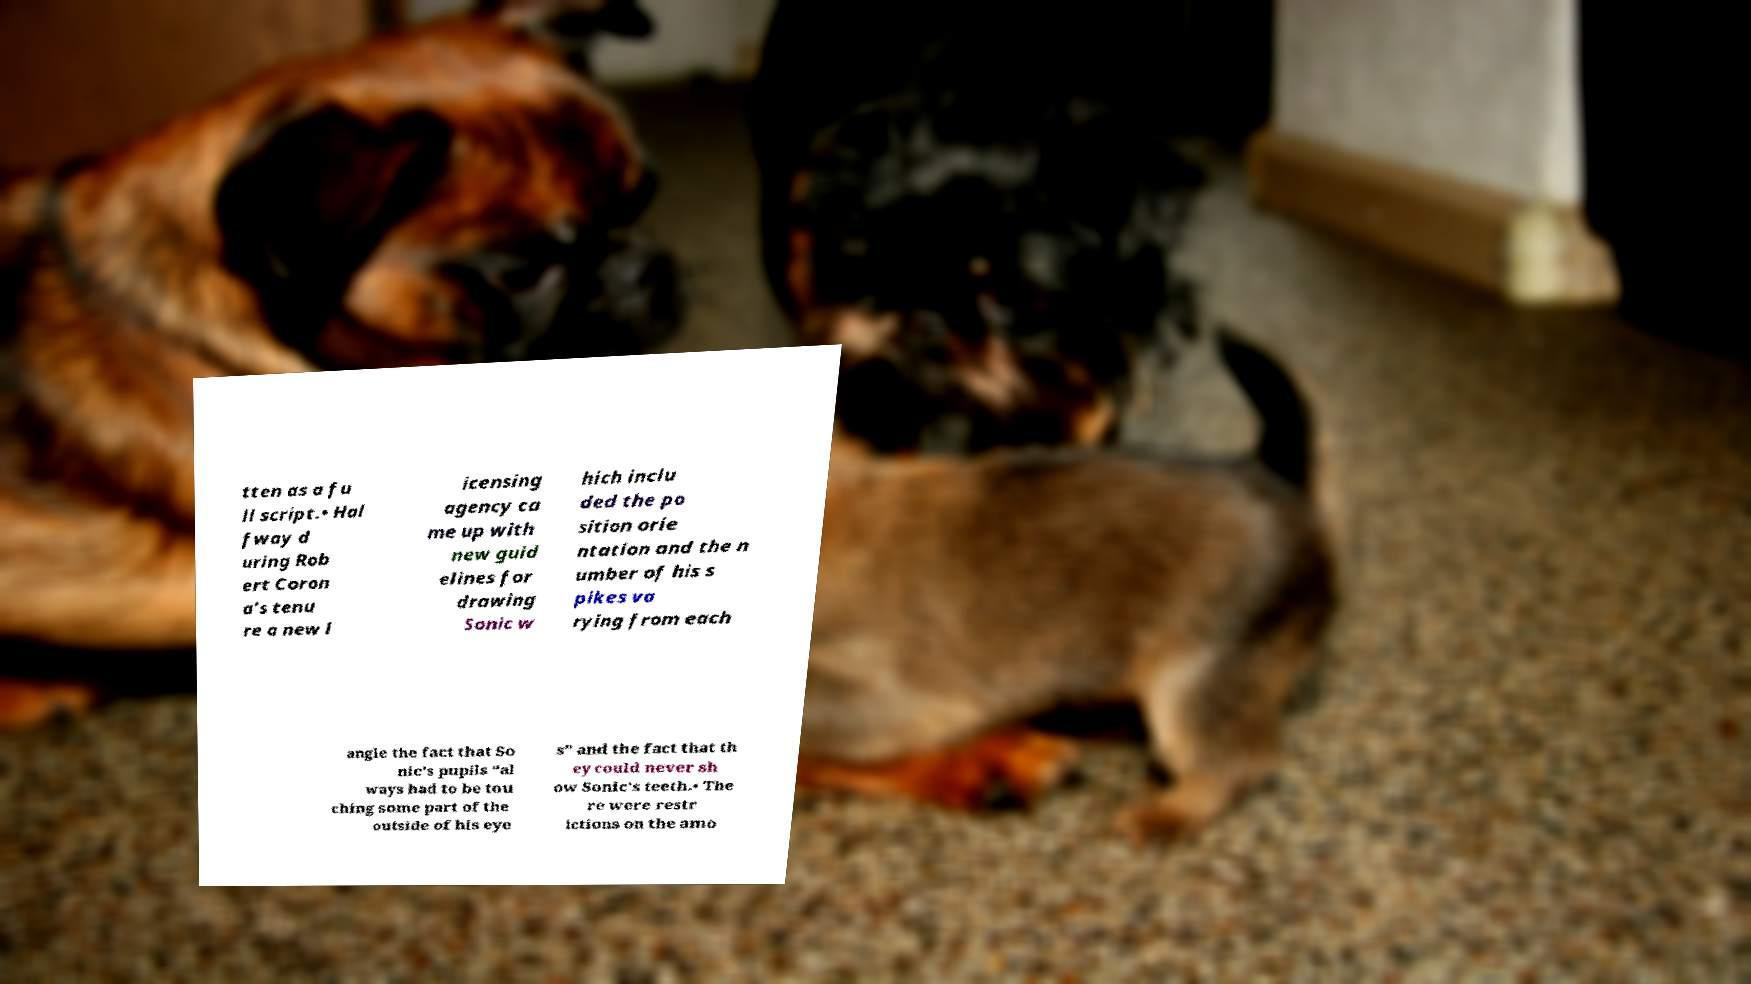Please identify and transcribe the text found in this image. tten as a fu ll script.• Hal fway d uring Rob ert Coron a’s tenu re a new l icensing agency ca me up with new guid elines for drawing Sonic w hich inclu ded the po sition orie ntation and the n umber of his s pikes va rying from each angle the fact that So nic’s pupils “al ways had to be tou ching some part of the outside of his eye s” and the fact that th ey could never sh ow Sonic’s teeth.• The re were restr ictions on the amo 